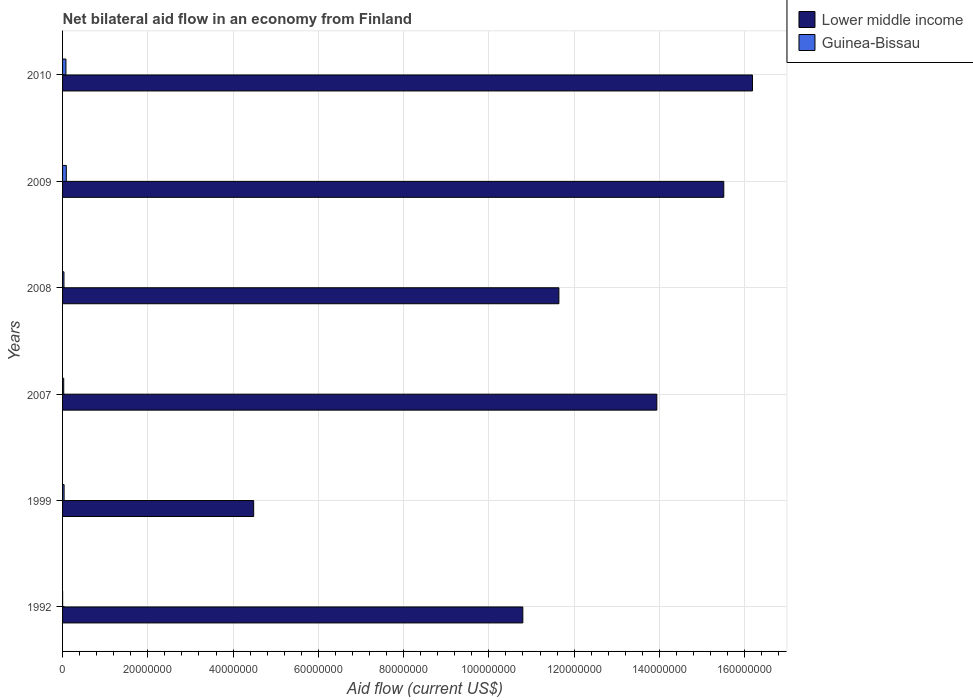How many different coloured bars are there?
Ensure brevity in your answer.  2. How many groups of bars are there?
Offer a terse response. 6. Are the number of bars on each tick of the Y-axis equal?
Offer a very short reply. Yes. How many bars are there on the 3rd tick from the top?
Make the answer very short. 2. How many bars are there on the 4th tick from the bottom?
Give a very brief answer. 2. What is the net bilateral aid flow in Guinea-Bissau in 2010?
Keep it short and to the point. 7.90e+05. Across all years, what is the maximum net bilateral aid flow in Lower middle income?
Provide a succinct answer. 1.62e+08. Across all years, what is the minimum net bilateral aid flow in Lower middle income?
Your answer should be very brief. 4.48e+07. In which year was the net bilateral aid flow in Lower middle income maximum?
Provide a short and direct response. 2010. What is the total net bilateral aid flow in Lower middle income in the graph?
Offer a very short reply. 7.26e+08. What is the difference between the net bilateral aid flow in Lower middle income in 1999 and that in 2009?
Make the answer very short. -1.10e+08. What is the difference between the net bilateral aid flow in Guinea-Bissau in 2009 and the net bilateral aid flow in Lower middle income in 2008?
Ensure brevity in your answer.  -1.16e+08. In the year 2008, what is the difference between the net bilateral aid flow in Lower middle income and net bilateral aid flow in Guinea-Bissau?
Make the answer very short. 1.16e+08. In how many years, is the net bilateral aid flow in Guinea-Bissau greater than 44000000 US$?
Your response must be concise. 0. What is the ratio of the net bilateral aid flow in Lower middle income in 2008 to that in 2010?
Your answer should be compact. 0.72. Is the difference between the net bilateral aid flow in Lower middle income in 1999 and 2009 greater than the difference between the net bilateral aid flow in Guinea-Bissau in 1999 and 2009?
Keep it short and to the point. No. What is the difference between the highest and the lowest net bilateral aid flow in Guinea-Bissau?
Keep it short and to the point. 8.70e+05. In how many years, is the net bilateral aid flow in Lower middle income greater than the average net bilateral aid flow in Lower middle income taken over all years?
Keep it short and to the point. 3. What does the 2nd bar from the top in 2010 represents?
Provide a succinct answer. Lower middle income. What does the 2nd bar from the bottom in 2009 represents?
Make the answer very short. Guinea-Bissau. How many bars are there?
Provide a succinct answer. 12. How many years are there in the graph?
Ensure brevity in your answer.  6. Does the graph contain grids?
Your response must be concise. Yes. Where does the legend appear in the graph?
Ensure brevity in your answer.  Top right. How are the legend labels stacked?
Offer a terse response. Vertical. What is the title of the graph?
Make the answer very short. Net bilateral aid flow in an economy from Finland. What is the Aid flow (current US$) in Lower middle income in 1992?
Make the answer very short. 1.08e+08. What is the Aid flow (current US$) of Guinea-Bissau in 1992?
Ensure brevity in your answer.  10000. What is the Aid flow (current US$) in Lower middle income in 1999?
Your answer should be very brief. 4.48e+07. What is the Aid flow (current US$) in Lower middle income in 2007?
Make the answer very short. 1.39e+08. What is the Aid flow (current US$) in Guinea-Bissau in 2007?
Provide a succinct answer. 2.70e+05. What is the Aid flow (current US$) of Lower middle income in 2008?
Your answer should be compact. 1.16e+08. What is the Aid flow (current US$) of Lower middle income in 2009?
Your answer should be very brief. 1.55e+08. What is the Aid flow (current US$) in Guinea-Bissau in 2009?
Provide a short and direct response. 8.80e+05. What is the Aid flow (current US$) in Lower middle income in 2010?
Offer a very short reply. 1.62e+08. What is the Aid flow (current US$) of Guinea-Bissau in 2010?
Offer a very short reply. 7.90e+05. Across all years, what is the maximum Aid flow (current US$) of Lower middle income?
Your answer should be very brief. 1.62e+08. Across all years, what is the maximum Aid flow (current US$) in Guinea-Bissau?
Make the answer very short. 8.80e+05. Across all years, what is the minimum Aid flow (current US$) of Lower middle income?
Offer a very short reply. 4.48e+07. What is the total Aid flow (current US$) of Lower middle income in the graph?
Offer a terse response. 7.26e+08. What is the total Aid flow (current US$) of Guinea-Bissau in the graph?
Offer a very short reply. 2.64e+06. What is the difference between the Aid flow (current US$) in Lower middle income in 1992 and that in 1999?
Provide a succinct answer. 6.31e+07. What is the difference between the Aid flow (current US$) of Guinea-Bissau in 1992 and that in 1999?
Make the answer very short. -3.50e+05. What is the difference between the Aid flow (current US$) in Lower middle income in 1992 and that in 2007?
Provide a short and direct response. -3.14e+07. What is the difference between the Aid flow (current US$) in Lower middle income in 1992 and that in 2008?
Provide a short and direct response. -8.46e+06. What is the difference between the Aid flow (current US$) in Guinea-Bissau in 1992 and that in 2008?
Make the answer very short. -3.20e+05. What is the difference between the Aid flow (current US$) in Lower middle income in 1992 and that in 2009?
Offer a terse response. -4.71e+07. What is the difference between the Aid flow (current US$) in Guinea-Bissau in 1992 and that in 2009?
Ensure brevity in your answer.  -8.70e+05. What is the difference between the Aid flow (current US$) in Lower middle income in 1992 and that in 2010?
Give a very brief answer. -5.39e+07. What is the difference between the Aid flow (current US$) in Guinea-Bissau in 1992 and that in 2010?
Your answer should be compact. -7.80e+05. What is the difference between the Aid flow (current US$) of Lower middle income in 1999 and that in 2007?
Your response must be concise. -9.46e+07. What is the difference between the Aid flow (current US$) of Guinea-Bissau in 1999 and that in 2007?
Offer a very short reply. 9.00e+04. What is the difference between the Aid flow (current US$) in Lower middle income in 1999 and that in 2008?
Make the answer very short. -7.16e+07. What is the difference between the Aid flow (current US$) of Lower middle income in 1999 and that in 2009?
Your response must be concise. -1.10e+08. What is the difference between the Aid flow (current US$) of Guinea-Bissau in 1999 and that in 2009?
Ensure brevity in your answer.  -5.20e+05. What is the difference between the Aid flow (current US$) of Lower middle income in 1999 and that in 2010?
Your response must be concise. -1.17e+08. What is the difference between the Aid flow (current US$) of Guinea-Bissau in 1999 and that in 2010?
Make the answer very short. -4.30e+05. What is the difference between the Aid flow (current US$) in Lower middle income in 2007 and that in 2008?
Offer a very short reply. 2.30e+07. What is the difference between the Aid flow (current US$) in Guinea-Bissau in 2007 and that in 2008?
Provide a short and direct response. -6.00e+04. What is the difference between the Aid flow (current US$) of Lower middle income in 2007 and that in 2009?
Ensure brevity in your answer.  -1.57e+07. What is the difference between the Aid flow (current US$) in Guinea-Bissau in 2007 and that in 2009?
Make the answer very short. -6.10e+05. What is the difference between the Aid flow (current US$) of Lower middle income in 2007 and that in 2010?
Ensure brevity in your answer.  -2.24e+07. What is the difference between the Aid flow (current US$) of Guinea-Bissau in 2007 and that in 2010?
Your response must be concise. -5.20e+05. What is the difference between the Aid flow (current US$) in Lower middle income in 2008 and that in 2009?
Your response must be concise. -3.87e+07. What is the difference between the Aid flow (current US$) of Guinea-Bissau in 2008 and that in 2009?
Keep it short and to the point. -5.50e+05. What is the difference between the Aid flow (current US$) of Lower middle income in 2008 and that in 2010?
Your answer should be very brief. -4.54e+07. What is the difference between the Aid flow (current US$) of Guinea-Bissau in 2008 and that in 2010?
Offer a terse response. -4.60e+05. What is the difference between the Aid flow (current US$) in Lower middle income in 2009 and that in 2010?
Your answer should be very brief. -6.73e+06. What is the difference between the Aid flow (current US$) in Guinea-Bissau in 2009 and that in 2010?
Offer a very short reply. 9.00e+04. What is the difference between the Aid flow (current US$) in Lower middle income in 1992 and the Aid flow (current US$) in Guinea-Bissau in 1999?
Provide a short and direct response. 1.08e+08. What is the difference between the Aid flow (current US$) of Lower middle income in 1992 and the Aid flow (current US$) of Guinea-Bissau in 2007?
Ensure brevity in your answer.  1.08e+08. What is the difference between the Aid flow (current US$) of Lower middle income in 1992 and the Aid flow (current US$) of Guinea-Bissau in 2008?
Offer a terse response. 1.08e+08. What is the difference between the Aid flow (current US$) of Lower middle income in 1992 and the Aid flow (current US$) of Guinea-Bissau in 2009?
Offer a very short reply. 1.07e+08. What is the difference between the Aid flow (current US$) of Lower middle income in 1992 and the Aid flow (current US$) of Guinea-Bissau in 2010?
Offer a very short reply. 1.07e+08. What is the difference between the Aid flow (current US$) in Lower middle income in 1999 and the Aid flow (current US$) in Guinea-Bissau in 2007?
Offer a terse response. 4.46e+07. What is the difference between the Aid flow (current US$) in Lower middle income in 1999 and the Aid flow (current US$) in Guinea-Bissau in 2008?
Keep it short and to the point. 4.45e+07. What is the difference between the Aid flow (current US$) of Lower middle income in 1999 and the Aid flow (current US$) of Guinea-Bissau in 2009?
Provide a short and direct response. 4.40e+07. What is the difference between the Aid flow (current US$) in Lower middle income in 1999 and the Aid flow (current US$) in Guinea-Bissau in 2010?
Offer a very short reply. 4.40e+07. What is the difference between the Aid flow (current US$) of Lower middle income in 2007 and the Aid flow (current US$) of Guinea-Bissau in 2008?
Ensure brevity in your answer.  1.39e+08. What is the difference between the Aid flow (current US$) of Lower middle income in 2007 and the Aid flow (current US$) of Guinea-Bissau in 2009?
Give a very brief answer. 1.39e+08. What is the difference between the Aid flow (current US$) of Lower middle income in 2007 and the Aid flow (current US$) of Guinea-Bissau in 2010?
Make the answer very short. 1.39e+08. What is the difference between the Aid flow (current US$) of Lower middle income in 2008 and the Aid flow (current US$) of Guinea-Bissau in 2009?
Your response must be concise. 1.16e+08. What is the difference between the Aid flow (current US$) in Lower middle income in 2008 and the Aid flow (current US$) in Guinea-Bissau in 2010?
Keep it short and to the point. 1.16e+08. What is the difference between the Aid flow (current US$) of Lower middle income in 2009 and the Aid flow (current US$) of Guinea-Bissau in 2010?
Keep it short and to the point. 1.54e+08. What is the average Aid flow (current US$) in Lower middle income per year?
Make the answer very short. 1.21e+08. In the year 1992, what is the difference between the Aid flow (current US$) of Lower middle income and Aid flow (current US$) of Guinea-Bissau?
Provide a short and direct response. 1.08e+08. In the year 1999, what is the difference between the Aid flow (current US$) in Lower middle income and Aid flow (current US$) in Guinea-Bissau?
Give a very brief answer. 4.45e+07. In the year 2007, what is the difference between the Aid flow (current US$) in Lower middle income and Aid flow (current US$) in Guinea-Bissau?
Your response must be concise. 1.39e+08. In the year 2008, what is the difference between the Aid flow (current US$) in Lower middle income and Aid flow (current US$) in Guinea-Bissau?
Give a very brief answer. 1.16e+08. In the year 2009, what is the difference between the Aid flow (current US$) of Lower middle income and Aid flow (current US$) of Guinea-Bissau?
Your answer should be compact. 1.54e+08. In the year 2010, what is the difference between the Aid flow (current US$) in Lower middle income and Aid flow (current US$) in Guinea-Bissau?
Ensure brevity in your answer.  1.61e+08. What is the ratio of the Aid flow (current US$) in Lower middle income in 1992 to that in 1999?
Offer a terse response. 2.41. What is the ratio of the Aid flow (current US$) of Guinea-Bissau in 1992 to that in 1999?
Provide a short and direct response. 0.03. What is the ratio of the Aid flow (current US$) in Lower middle income in 1992 to that in 2007?
Your answer should be very brief. 0.77. What is the ratio of the Aid flow (current US$) in Guinea-Bissau in 1992 to that in 2007?
Keep it short and to the point. 0.04. What is the ratio of the Aid flow (current US$) in Lower middle income in 1992 to that in 2008?
Give a very brief answer. 0.93. What is the ratio of the Aid flow (current US$) of Guinea-Bissau in 1992 to that in 2008?
Offer a very short reply. 0.03. What is the ratio of the Aid flow (current US$) of Lower middle income in 1992 to that in 2009?
Your answer should be compact. 0.7. What is the ratio of the Aid flow (current US$) of Guinea-Bissau in 1992 to that in 2009?
Offer a terse response. 0.01. What is the ratio of the Aid flow (current US$) in Lower middle income in 1992 to that in 2010?
Keep it short and to the point. 0.67. What is the ratio of the Aid flow (current US$) of Guinea-Bissau in 1992 to that in 2010?
Offer a terse response. 0.01. What is the ratio of the Aid flow (current US$) in Lower middle income in 1999 to that in 2007?
Offer a terse response. 0.32. What is the ratio of the Aid flow (current US$) in Guinea-Bissau in 1999 to that in 2007?
Your response must be concise. 1.33. What is the ratio of the Aid flow (current US$) of Lower middle income in 1999 to that in 2008?
Offer a very short reply. 0.39. What is the ratio of the Aid flow (current US$) in Lower middle income in 1999 to that in 2009?
Make the answer very short. 0.29. What is the ratio of the Aid flow (current US$) of Guinea-Bissau in 1999 to that in 2009?
Provide a succinct answer. 0.41. What is the ratio of the Aid flow (current US$) of Lower middle income in 1999 to that in 2010?
Provide a succinct answer. 0.28. What is the ratio of the Aid flow (current US$) in Guinea-Bissau in 1999 to that in 2010?
Provide a succinct answer. 0.46. What is the ratio of the Aid flow (current US$) of Lower middle income in 2007 to that in 2008?
Make the answer very short. 1.2. What is the ratio of the Aid flow (current US$) of Guinea-Bissau in 2007 to that in 2008?
Offer a very short reply. 0.82. What is the ratio of the Aid flow (current US$) in Lower middle income in 2007 to that in 2009?
Give a very brief answer. 0.9. What is the ratio of the Aid flow (current US$) of Guinea-Bissau in 2007 to that in 2009?
Offer a very short reply. 0.31. What is the ratio of the Aid flow (current US$) of Lower middle income in 2007 to that in 2010?
Provide a succinct answer. 0.86. What is the ratio of the Aid flow (current US$) of Guinea-Bissau in 2007 to that in 2010?
Give a very brief answer. 0.34. What is the ratio of the Aid flow (current US$) in Lower middle income in 2008 to that in 2009?
Provide a succinct answer. 0.75. What is the ratio of the Aid flow (current US$) of Lower middle income in 2008 to that in 2010?
Offer a terse response. 0.72. What is the ratio of the Aid flow (current US$) of Guinea-Bissau in 2008 to that in 2010?
Keep it short and to the point. 0.42. What is the ratio of the Aid flow (current US$) in Lower middle income in 2009 to that in 2010?
Provide a succinct answer. 0.96. What is the ratio of the Aid flow (current US$) of Guinea-Bissau in 2009 to that in 2010?
Provide a short and direct response. 1.11. What is the difference between the highest and the second highest Aid flow (current US$) of Lower middle income?
Offer a very short reply. 6.73e+06. What is the difference between the highest and the lowest Aid flow (current US$) of Lower middle income?
Offer a terse response. 1.17e+08. What is the difference between the highest and the lowest Aid flow (current US$) of Guinea-Bissau?
Keep it short and to the point. 8.70e+05. 